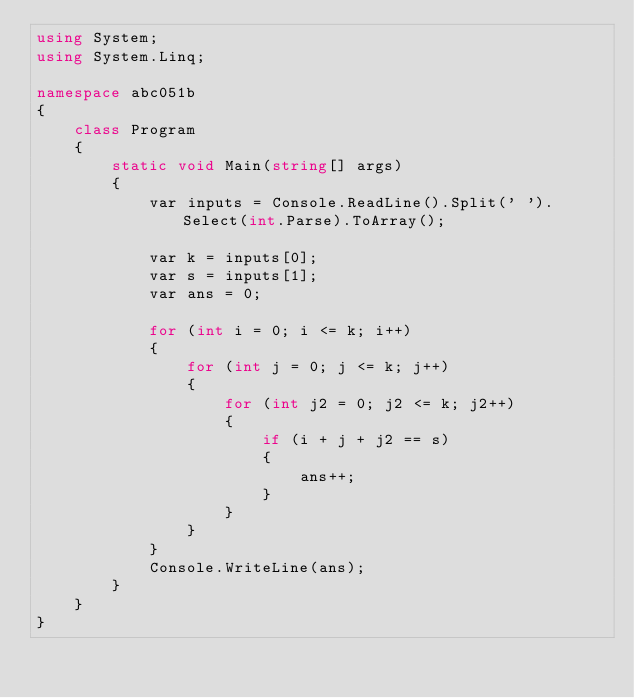<code> <loc_0><loc_0><loc_500><loc_500><_C#_>using System;
using System.Linq;

namespace abc051b
{
    class Program
    {
        static void Main(string[] args)
        {
            var inputs = Console.ReadLine().Split(' ').Select(int.Parse).ToArray();

            var k = inputs[0];
            var s = inputs[1];
            var ans = 0;

            for (int i = 0; i <= k; i++)
            {
                for (int j = 0; j <= k; j++)
                {
                    for (int j2 = 0; j2 <= k; j2++)
                    {
                        if (i + j + j2 == s)
                        {
                            ans++;
                        }
                    }
                }
            }
            Console.WriteLine(ans);
        }
    }
}
</code> 